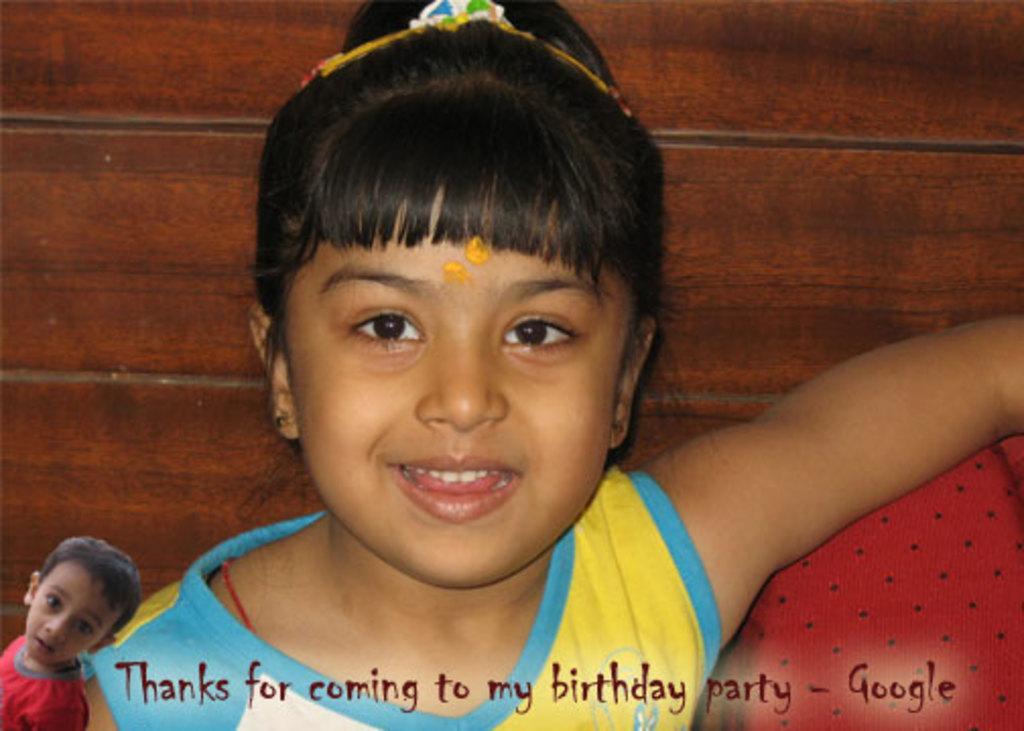Describe this image in one or two sentences. As we can see in the image there is a girl sitting on sofa. 